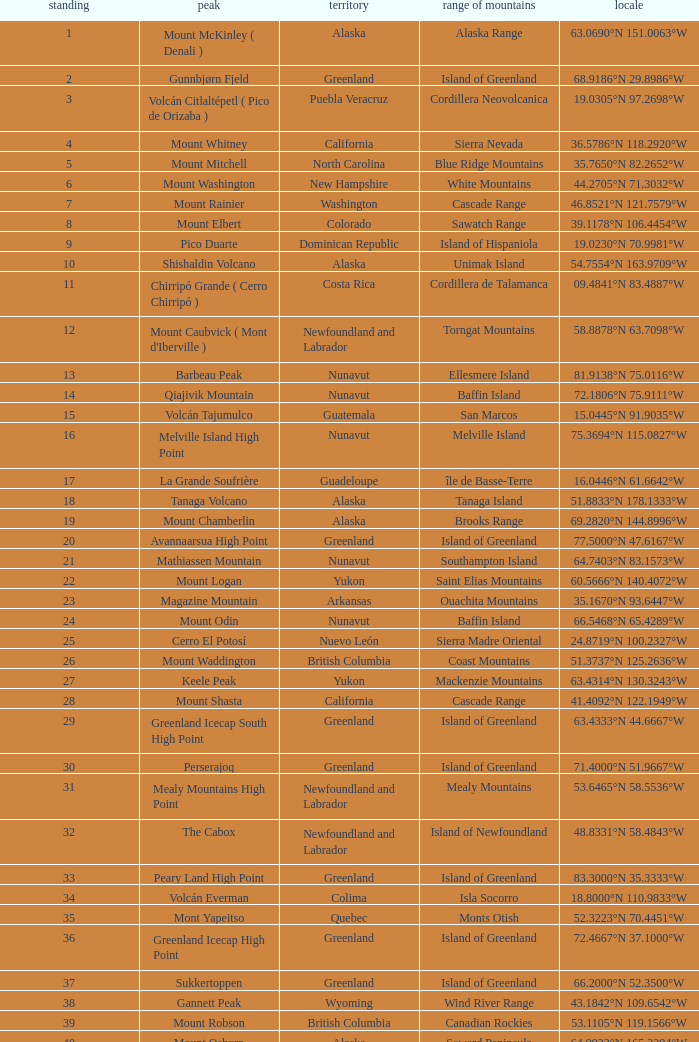Which Mountain Range has a Region of haiti, and a Location of 18.3601°n 71.9764°w? Island of Hispaniola. 